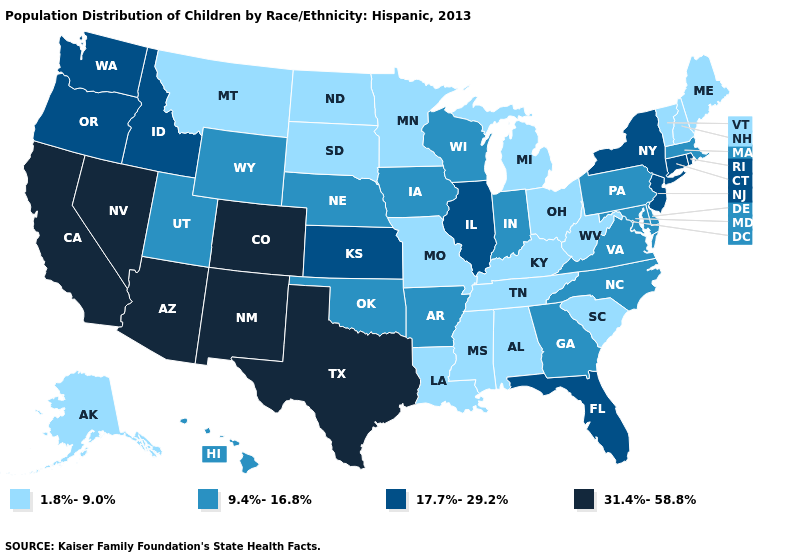Name the states that have a value in the range 17.7%-29.2%?
Give a very brief answer. Connecticut, Florida, Idaho, Illinois, Kansas, New Jersey, New York, Oregon, Rhode Island, Washington. Name the states that have a value in the range 17.7%-29.2%?
Write a very short answer. Connecticut, Florida, Idaho, Illinois, Kansas, New Jersey, New York, Oregon, Rhode Island, Washington. Does South Dakota have the highest value in the USA?
Keep it brief. No. Among the states that border Alabama , which have the highest value?
Be succinct. Florida. What is the highest value in the USA?
Write a very short answer. 31.4%-58.8%. Which states hav the highest value in the South?
Quick response, please. Texas. Is the legend a continuous bar?
Answer briefly. No. What is the highest value in states that border Nevada?
Answer briefly. 31.4%-58.8%. What is the value of Texas?
Keep it brief. 31.4%-58.8%. What is the value of New Hampshire?
Give a very brief answer. 1.8%-9.0%. Does Alaska have the lowest value in the USA?
Short answer required. Yes. What is the lowest value in the West?
Concise answer only. 1.8%-9.0%. What is the lowest value in the MidWest?
Quick response, please. 1.8%-9.0%. Which states have the highest value in the USA?
Give a very brief answer. Arizona, California, Colorado, Nevada, New Mexico, Texas. How many symbols are there in the legend?
Keep it brief. 4. 